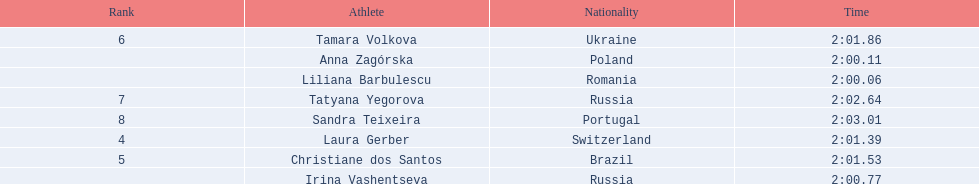What are the names of the competitors? Liliana Barbulescu, Anna Zagórska, Irina Vashentseva, Laura Gerber, Christiane dos Santos, Tamara Volkova, Tatyana Yegorova, Sandra Teixeira. Which finalist finished the fastest? Liliana Barbulescu. 